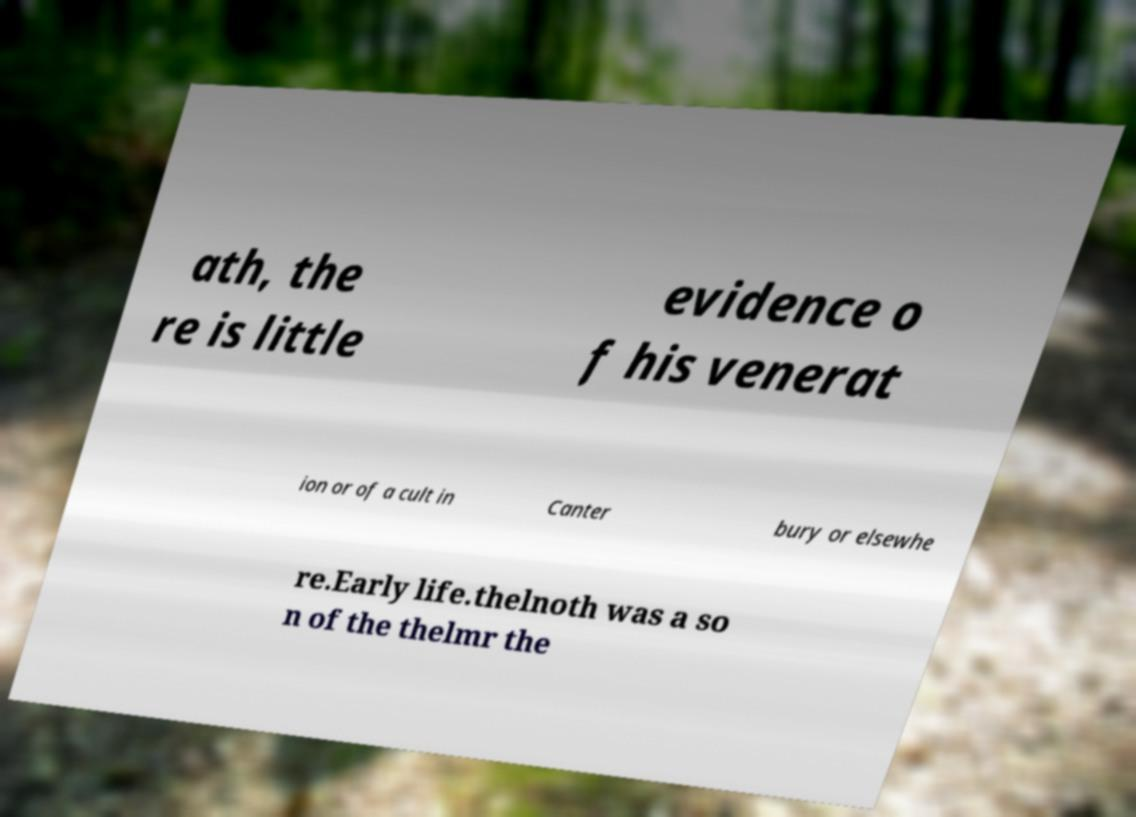Please identify and transcribe the text found in this image. ath, the re is little evidence o f his venerat ion or of a cult in Canter bury or elsewhe re.Early life.thelnoth was a so n of the thelmr the 